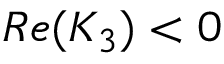Convert formula to latex. <formula><loc_0><loc_0><loc_500><loc_500>R e ( K _ { 3 } ) < 0</formula> 